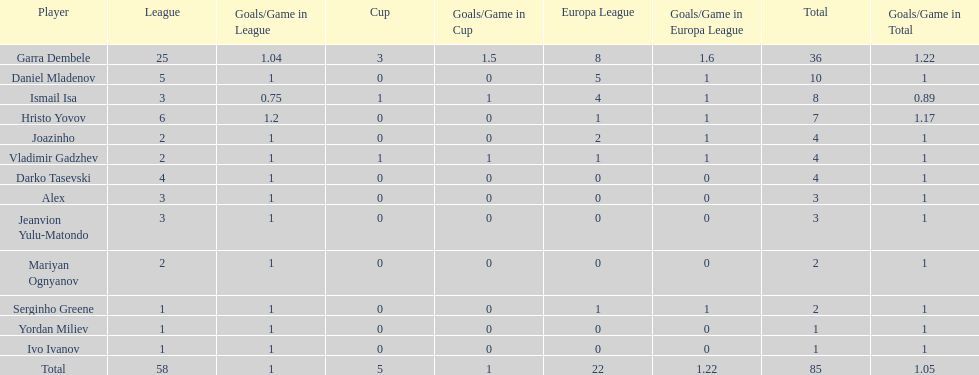Who are all of the players? Garra Dembele, Daniel Mladenov, Ismail Isa, Hristo Yovov, Joazinho, Vladimir Gadzhev, Darko Tasevski, Alex, Jeanvion Yulu-Matondo, Mariyan Ognyanov, Serginho Greene, Yordan Miliev, Ivo Ivanov. And which league is each player in? 25, 5, 3, 6, 2, 2, 4, 3, 3, 2, 1, 1, 1. Along with vladimir gadzhev and joazinho, which other player is in league 2? Mariyan Ognyanov. 